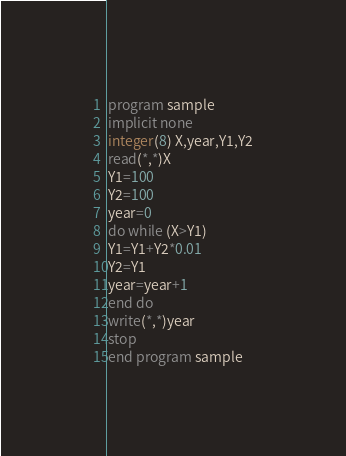Convert code to text. <code><loc_0><loc_0><loc_500><loc_500><_FORTRAN_>program sample
implicit none
integer(8) X,year,Y1,Y2
read(*,*)X
Y1=100
Y2=100
year=0
do while (X>Y1)
Y1=Y1+Y2*0.01
Y2=Y1
year=year+1
end do
write(*,*)year
stop
end program sample</code> 